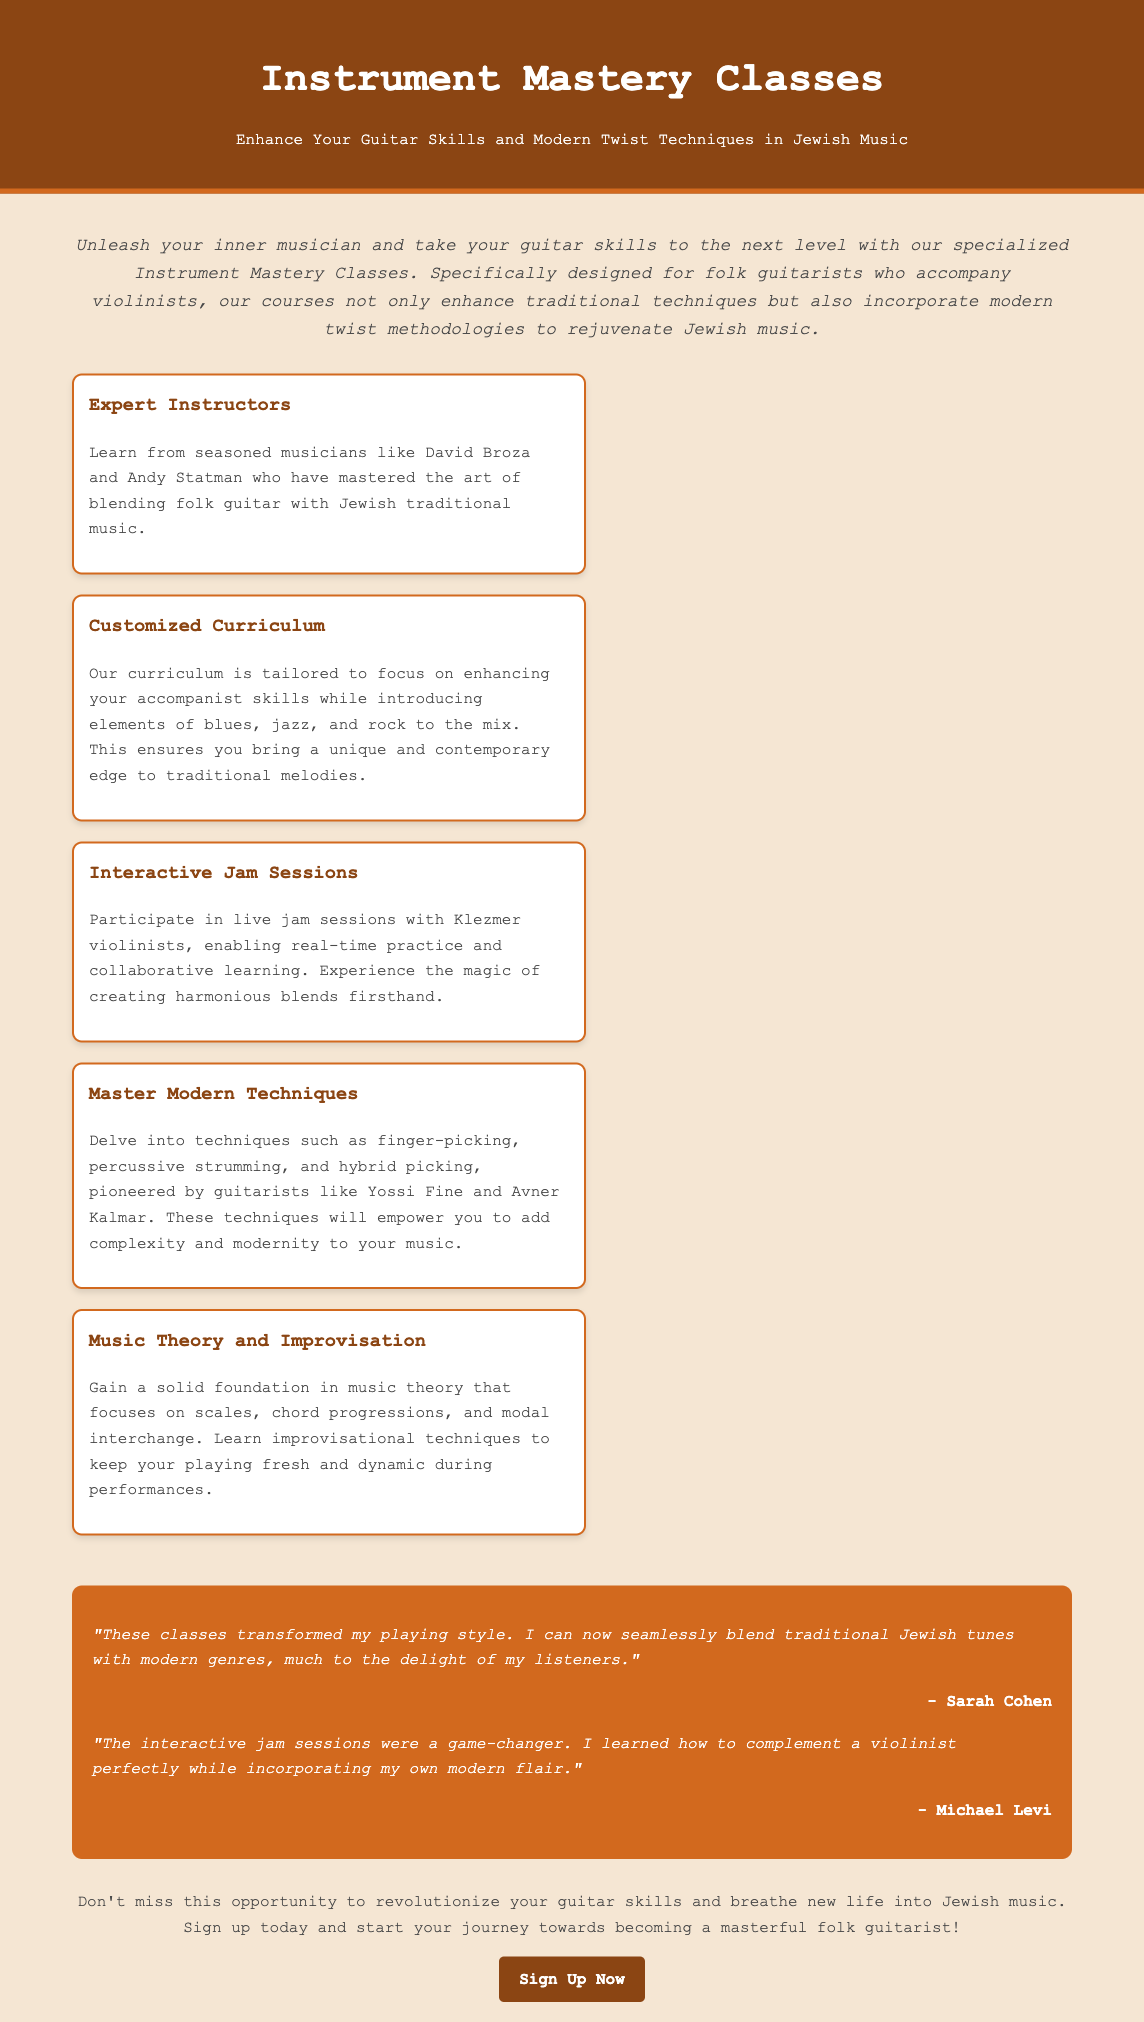What is the main focus of the classes? The main focus is to enhance guitar skills and modern twist techniques in Jewish music.
Answer: Enhance Your Guitar Skills and Modern Twist Techniques in Jewish Music Who are some expert instructors mentioned? The document lists seasoned musicians who are instructors in the classes.
Answer: David Broza and Andy Statman What kind of sessions are included in the classes? The document mentions a specific type of interactive musical gathering.
Answer: Interactive Jam Sessions What technique types are taught in the classes? The document lists various guitar techniques that students will learn.
Answer: Finger-picking, percussive strumming, and hybrid picking What is the purpose of the testimonials in the advertisement? The testimonials serve to provide feedback from previous students about the classes.
Answer: Game-changer feedback What should a potential student do to enroll in the classes? The document provides a call to action for enrollment.
Answer: Sign Up Now 